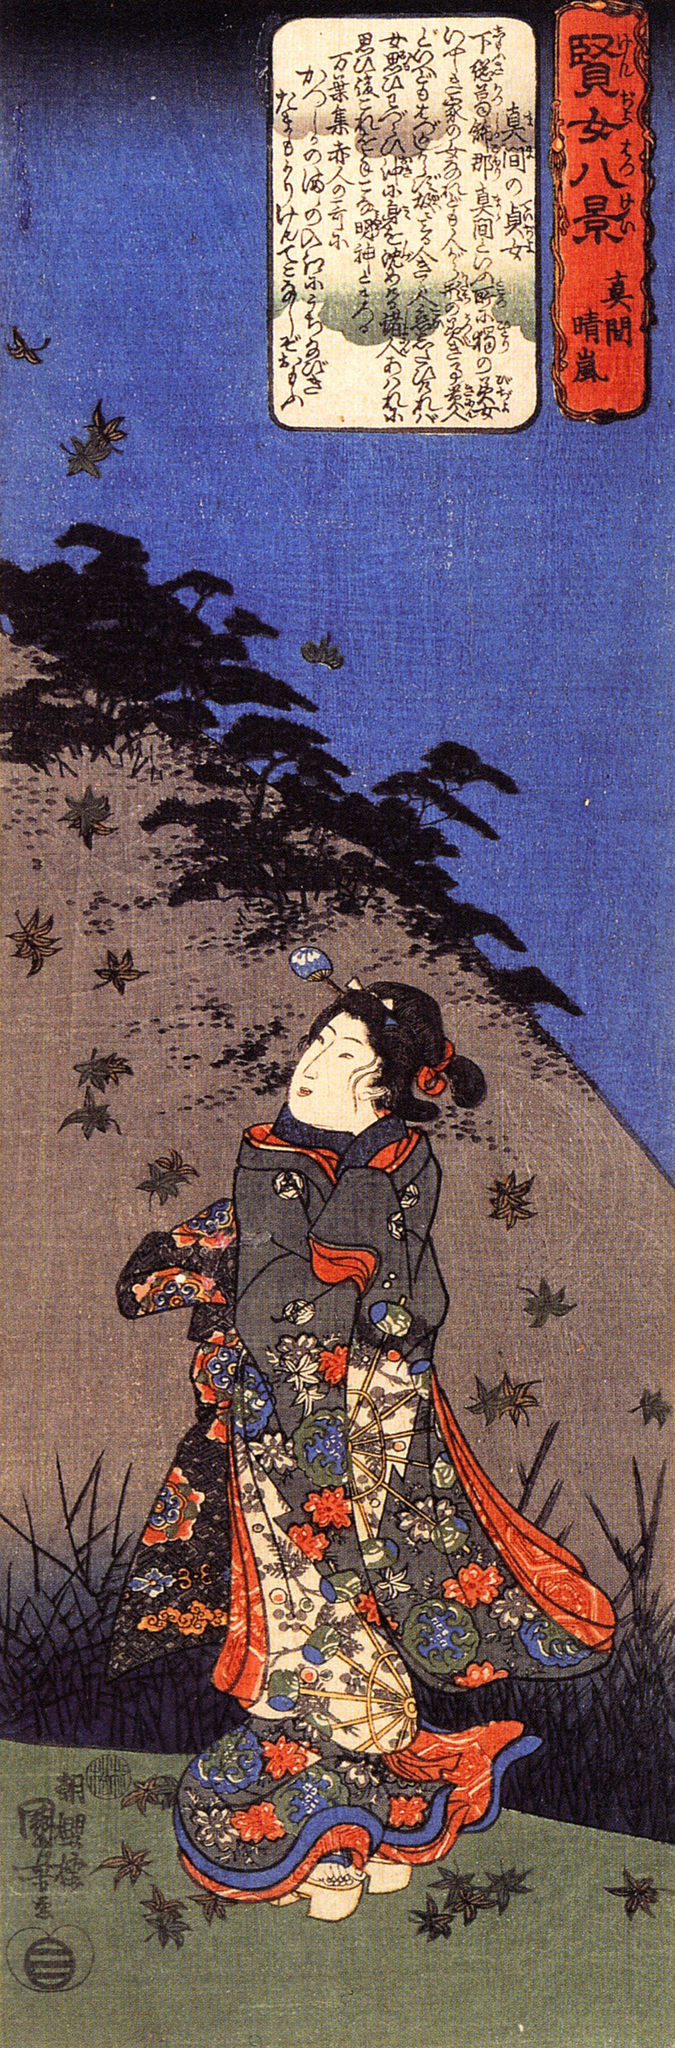Let's say the woman saw a magical creature in the sky. What would that creature look like and what message might it bring? As the woman gazes into the sky, she suddenly notices a shimmering creature emerging from the clouds. It is a majestic dragon, its scales gleaming in shades of emerald and sapphire, reflecting the colors of the evening sky. The dragon's wings are adorned with intricate patterns that resemble the delicate design of her kimono. With eyes that hold the wisdom of the ages, the dragon descends gracefully, enveloping the scene in a soft, golden light.

The dragon speaks in a voice that resonates with the gentle rustle of leaves and the whisper of ancient winds. It brings a message of harmony and balance, reminding the woman of the interconnectedness of all things. It tells her that just as her vibrant kimono is woven with threads of countless colors, life is woven with experiences and emotions, each essential and beautiful. The dragon encourages her to embrace her journey, with all its challenges and joys, and to find strength in the unity of the natural world and her own inner spirit. With this message, the dragon imparts a sense of purpose and serenity, before disappearing back into the ethereal realm, leaving behind a trail of sparkling stardust. 